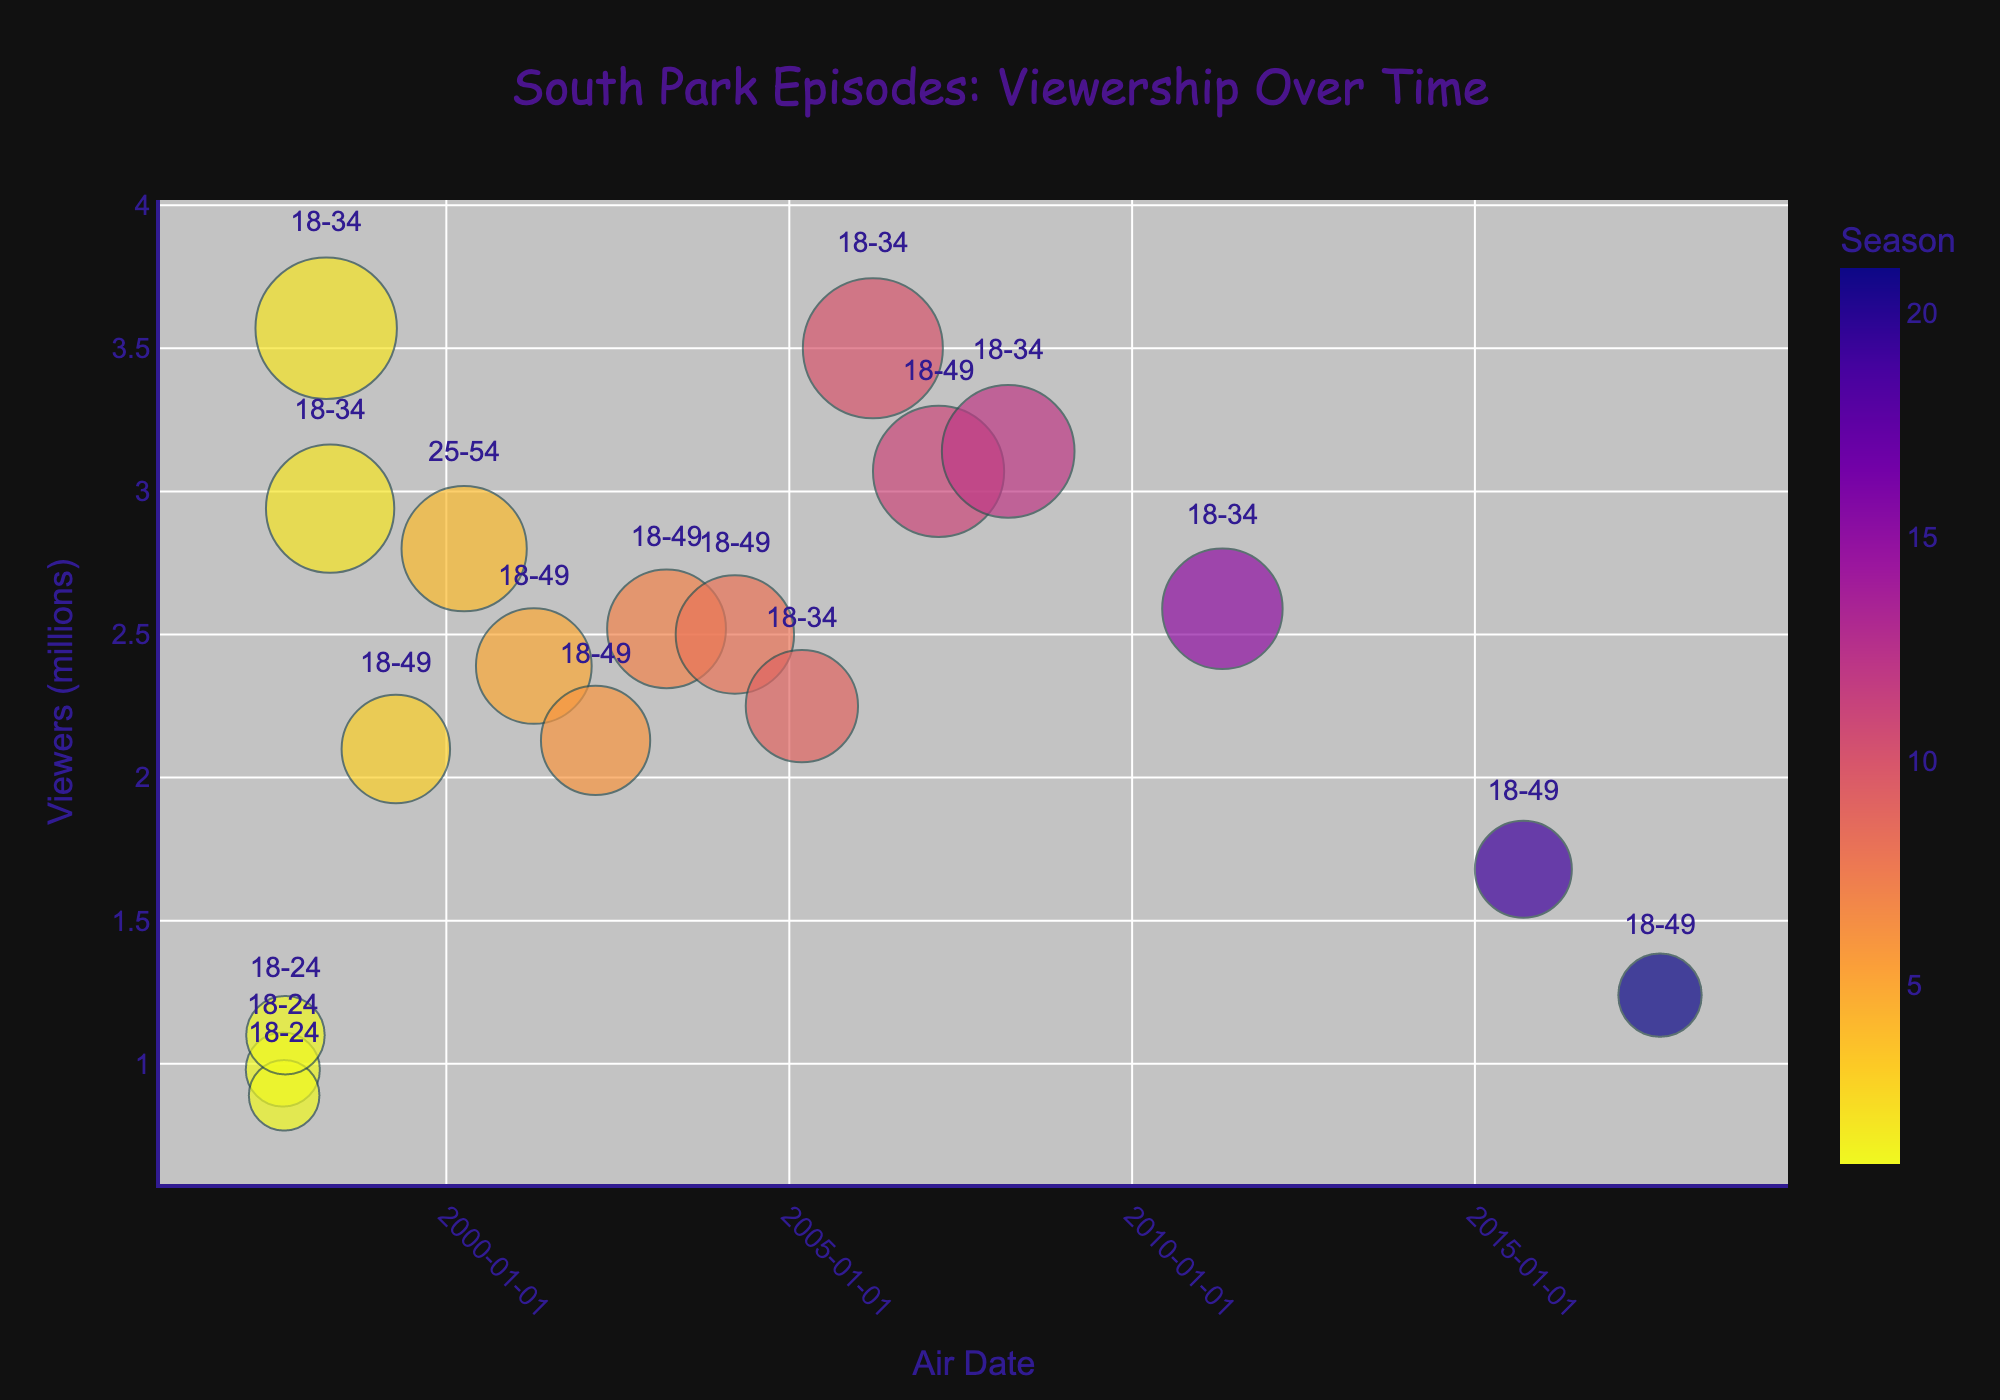Which season had the highest viewership for a single episode? By examining the size of the bubbles, the episode in Season 2 had the highest viewership because its bubble is the largest in the chart.
Answer: Season 2 What is the general trend in viewership over the years? Looking at the y-axis values over time, there is a decreasing trend in viewership as the series progresses from 1997 to 2017.
Answer: Decreasing How many episodes had over 3 million viewers? Identify bubbles with sizes representing viewership over 3 million; there are three such bubbles.
Answer: 3 Which age group had the most instances of high viewership (above 2.5 million)? The bubbles labeled with age groups show that episodes appealing to the 18-34 and 18-49 age groups had highest viewership. By counting, the 18-34 age group appears more frequently.
Answer: 18-34 Between which years did the episodes have an average viewership of around 2.5 million? By visually estimating the y-axis values, episodes around 2003-2011 have bubbles representing roughly 2.5 million viewers.
Answer: 2003-2011 How does the viewership of Season 1 compare to Season 10? By comparing the bubbles for these seasons, Season 10 has higher and larger viewership values compared to Season 1.
Answer: Season 10 had higher viewership Which episode had the lowest viewership and in which season? The smallest bubble indicates the lowest viewership, which is for Season 1, Episode 2.
Answer: Season 1, Episode 2 What is the range of viewership (in millions) in Season 2? Examining the bubbles’ sizes in Season 2, the viewership ranges from approximately 2.94 to 3.57 million.
Answer: 2.94-3.57 million Does the viewership pattern differ for episodes targeted at different age groups? By examining the distribution and size of the bubbles with different age group labels, we can see those targeted at older age groups (18-34 and 18-49) had more viewership variance and higher peaks.
Answer: Yes Which season had the lowest viewership for the first episode? The smallest bubble representing the viewership of a first episode is for Season 21.
Answer: Season 21 